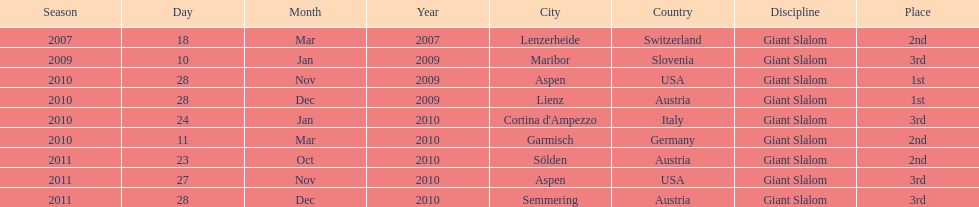The final race finishing place was not 1st but what other place? 3rd. 